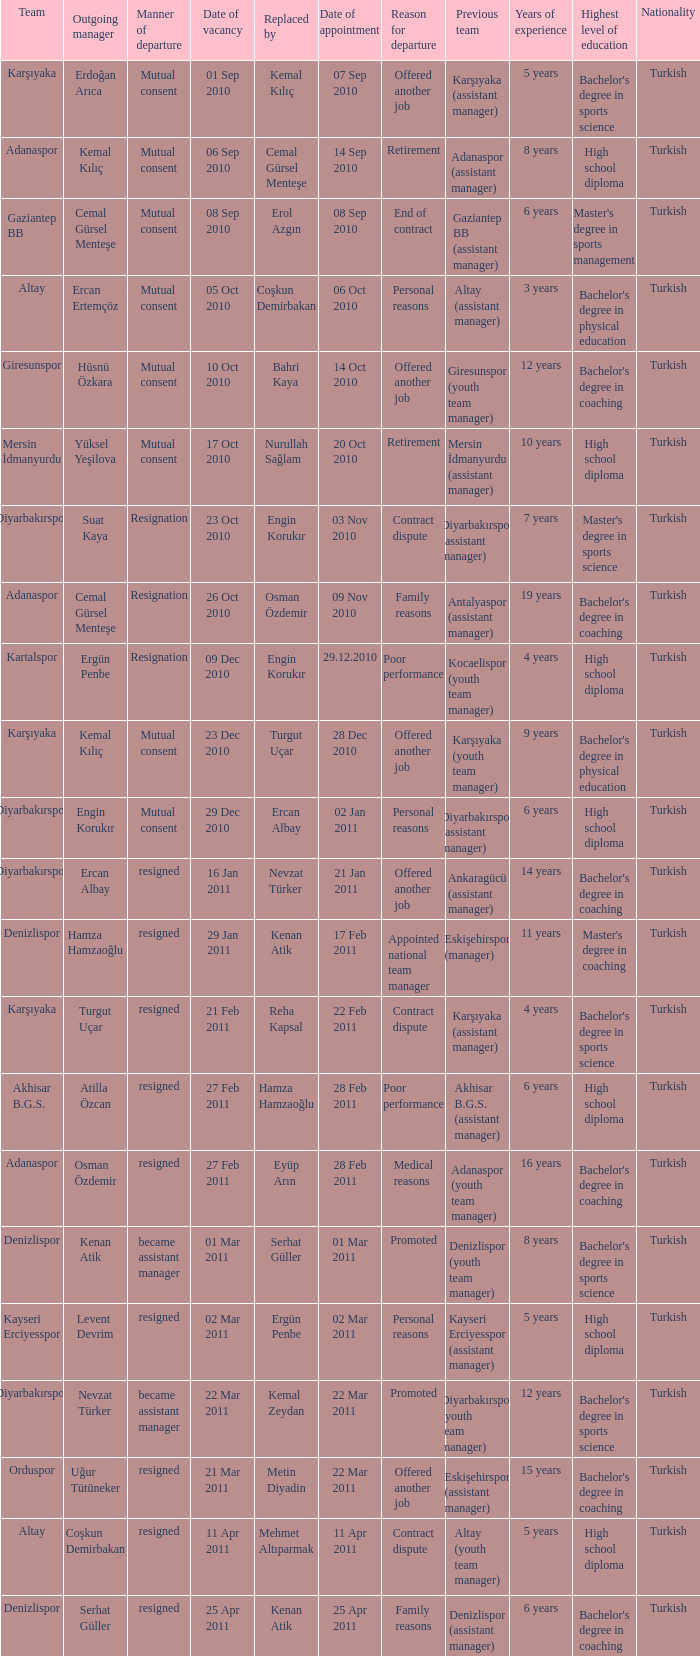Who replaced the outgoing manager Hüsnü Özkara?  Bahri Kaya. 